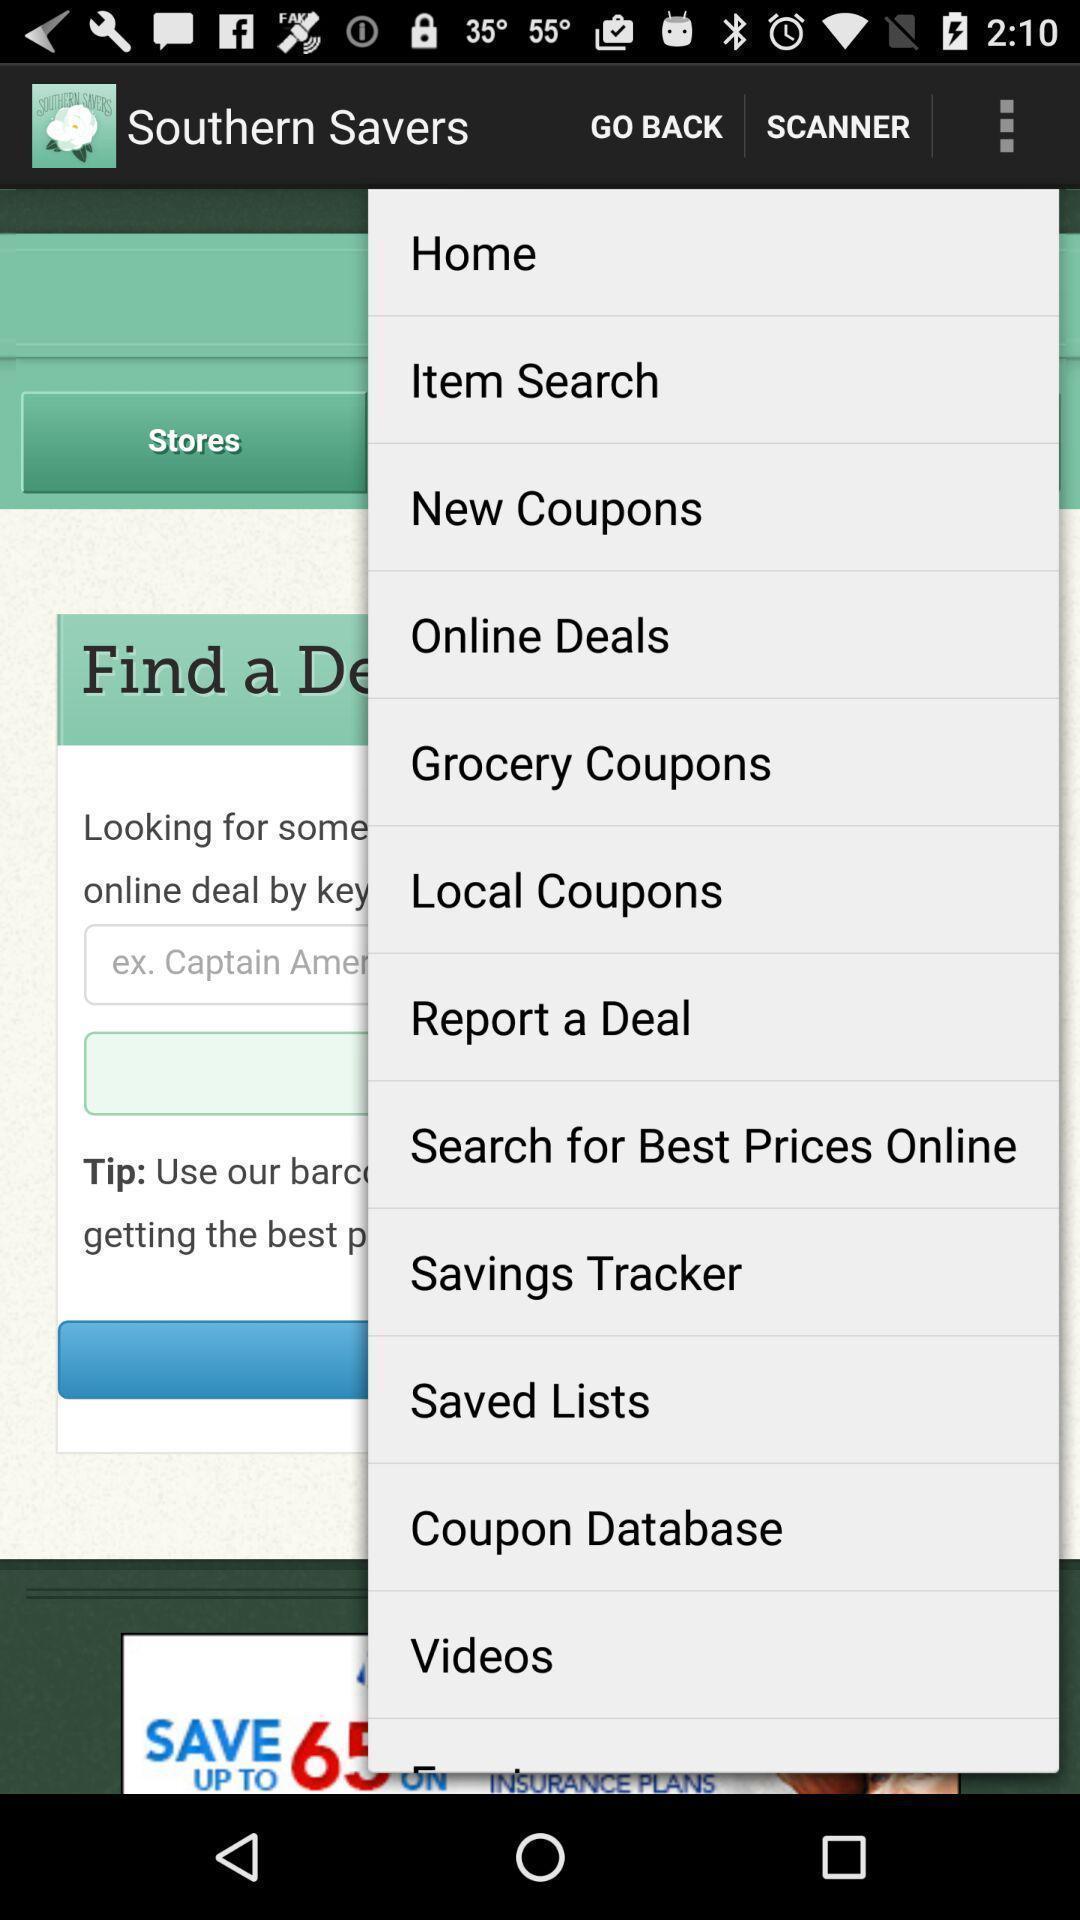Summarize the information in this screenshot. Page displays list of various options in app. 